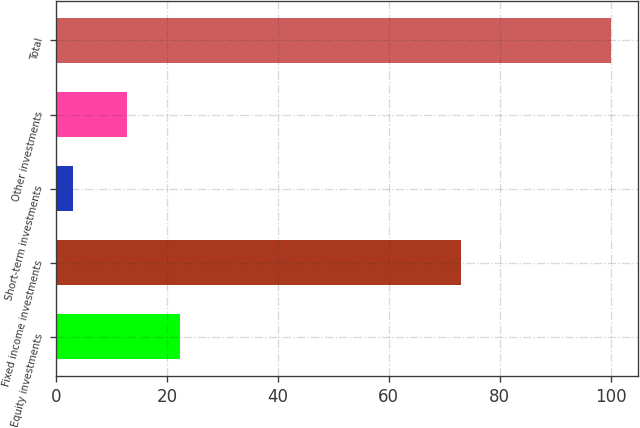<chart> <loc_0><loc_0><loc_500><loc_500><bar_chart><fcel>Equity investments<fcel>Fixed income investments<fcel>Short-term investments<fcel>Other investments<fcel>Total<nl><fcel>22.4<fcel>73<fcel>3<fcel>12.7<fcel>100<nl></chart> 